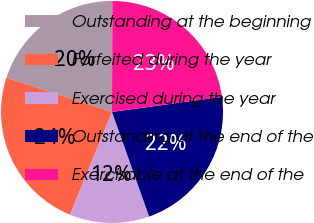Convert chart to OTSL. <chart><loc_0><loc_0><loc_500><loc_500><pie_chart><fcel>Outstanding at the beginning<fcel>Forfeited during the year<fcel>Exercised during the year<fcel>Outstanding at the end of the<fcel>Exercisable at the end of the<nl><fcel>20.06%<fcel>23.82%<fcel>11.6%<fcel>21.74%<fcel>22.78%<nl></chart> 